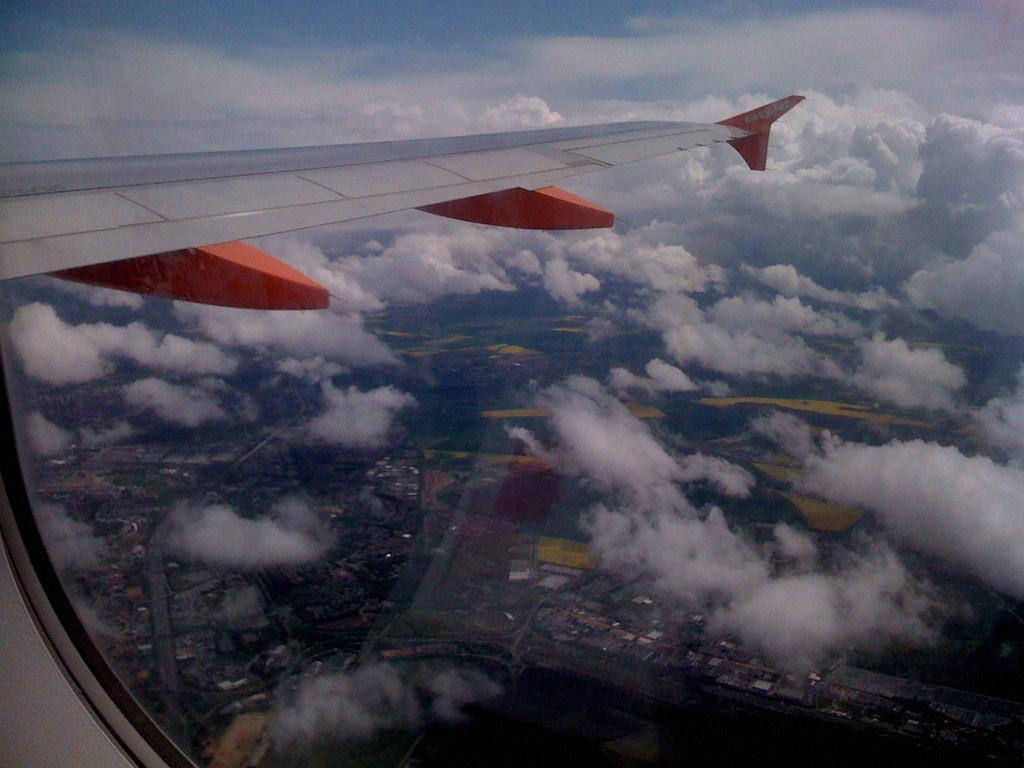What is the perspective of the image? The image is taken from an airplane. What can be seen in the sky in the image? There are clouds visible in the image. What is located at the bottom of the image? There are houses and trees at the bottom of the image. What type of humor can be seen in the trees in the image? There is no humor present in the trees in the image; they are simply trees. 